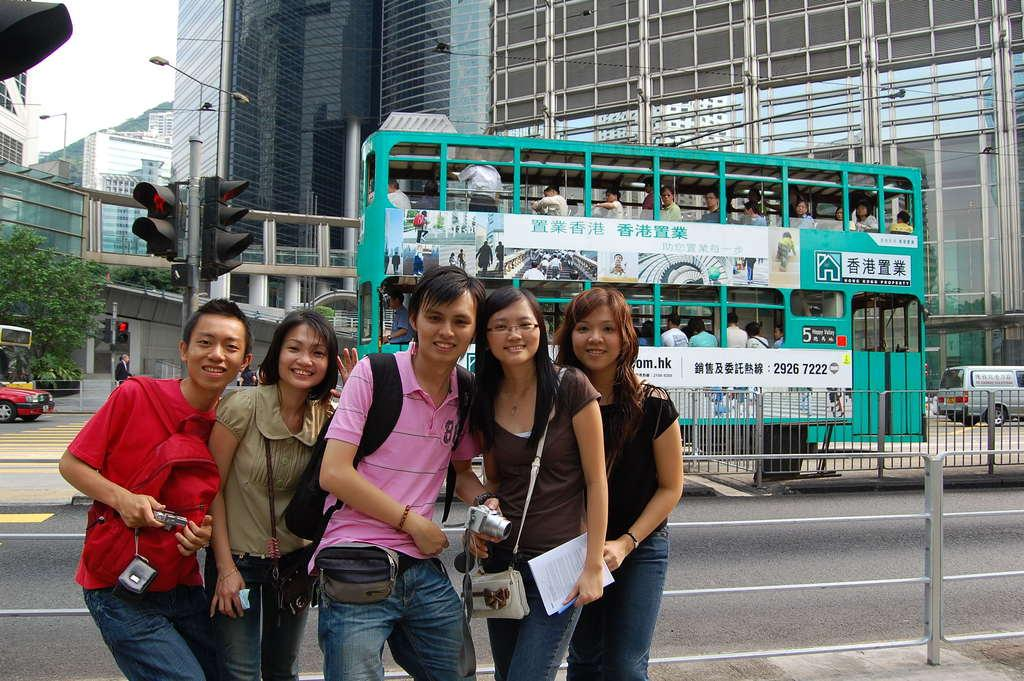<image>
Summarize the visual content of the image. Five people pose for a photo as the number 5 bus passes in the background. 